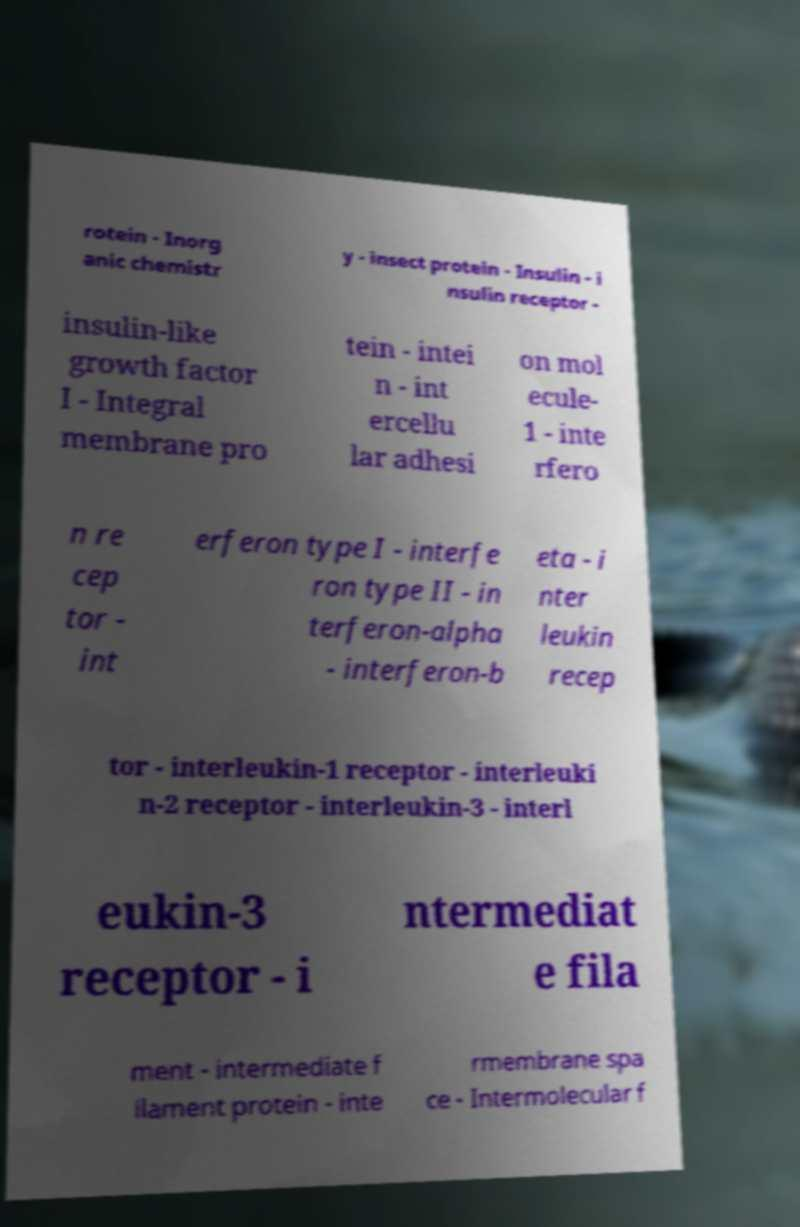Please read and relay the text visible in this image. What does it say? rotein - Inorg anic chemistr y - insect protein - Insulin - i nsulin receptor - insulin-like growth factor I - Integral membrane pro tein - intei n - int ercellu lar adhesi on mol ecule- 1 - inte rfero n re cep tor - int erferon type I - interfe ron type II - in terferon-alpha - interferon-b eta - i nter leukin recep tor - interleukin-1 receptor - interleuki n-2 receptor - interleukin-3 - interl eukin-3 receptor - i ntermediat e fila ment - intermediate f ilament protein - inte rmembrane spa ce - Intermolecular f 